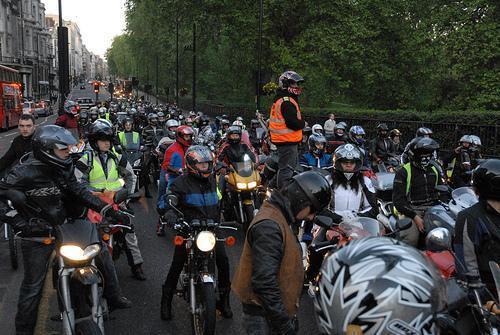How many motorcycles are in the picture?
Give a very brief answer. 4. How many people are there?
Give a very brief answer. 8. How many giraffes are not drinking?
Give a very brief answer. 0. 